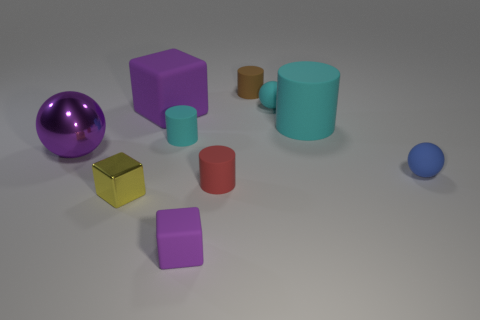Subtract all small red rubber cylinders. How many cylinders are left? 3 Subtract 3 cylinders. How many cylinders are left? 1 Subtract all yellow cubes. How many cubes are left? 2 Subtract all brown cylinders. How many purple blocks are left? 2 Subtract all balls. How many objects are left? 7 Subtract all yellow cylinders. Subtract all brown blocks. How many cylinders are left? 4 Subtract all yellow blocks. Subtract all small green rubber blocks. How many objects are left? 9 Add 4 small cyan rubber spheres. How many small cyan rubber spheres are left? 5 Add 5 large objects. How many large objects exist? 8 Subtract 1 cyan spheres. How many objects are left? 9 